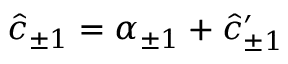Convert formula to latex. <formula><loc_0><loc_0><loc_500><loc_500>\hat { c } _ { \pm 1 } = \alpha _ { \pm 1 } + \hat { c } _ { \pm 1 } ^ { \prime }</formula> 